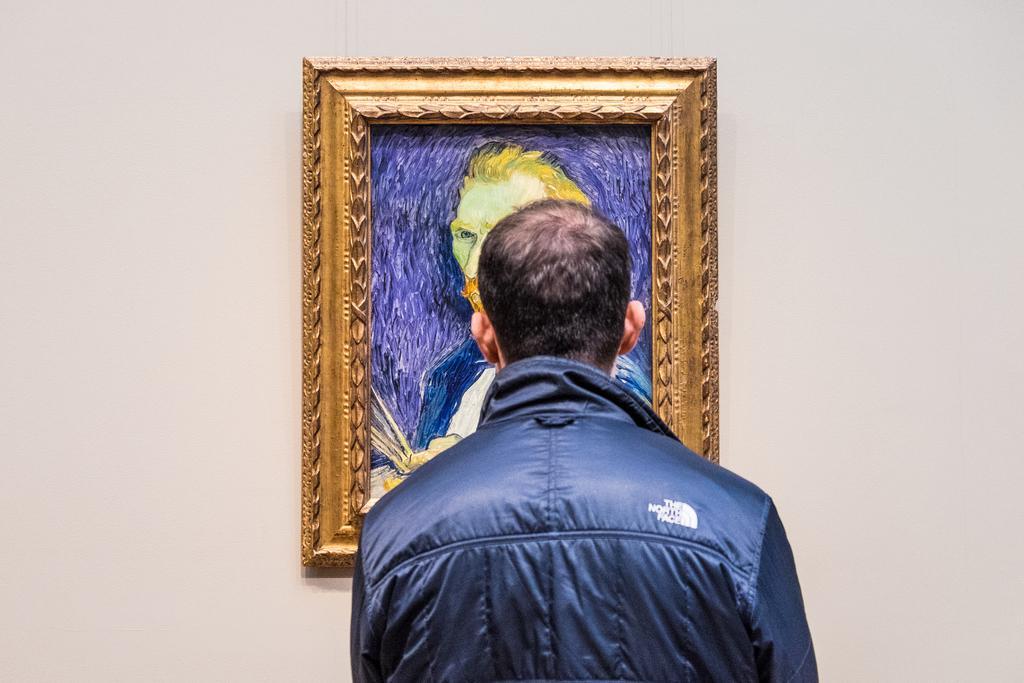In one or two sentences, can you explain what this image depicts? Here in this picture we can see a person who is wearing a jacket, standing over a place and in front of him on the wall we can see a painting present and he is watching it. 